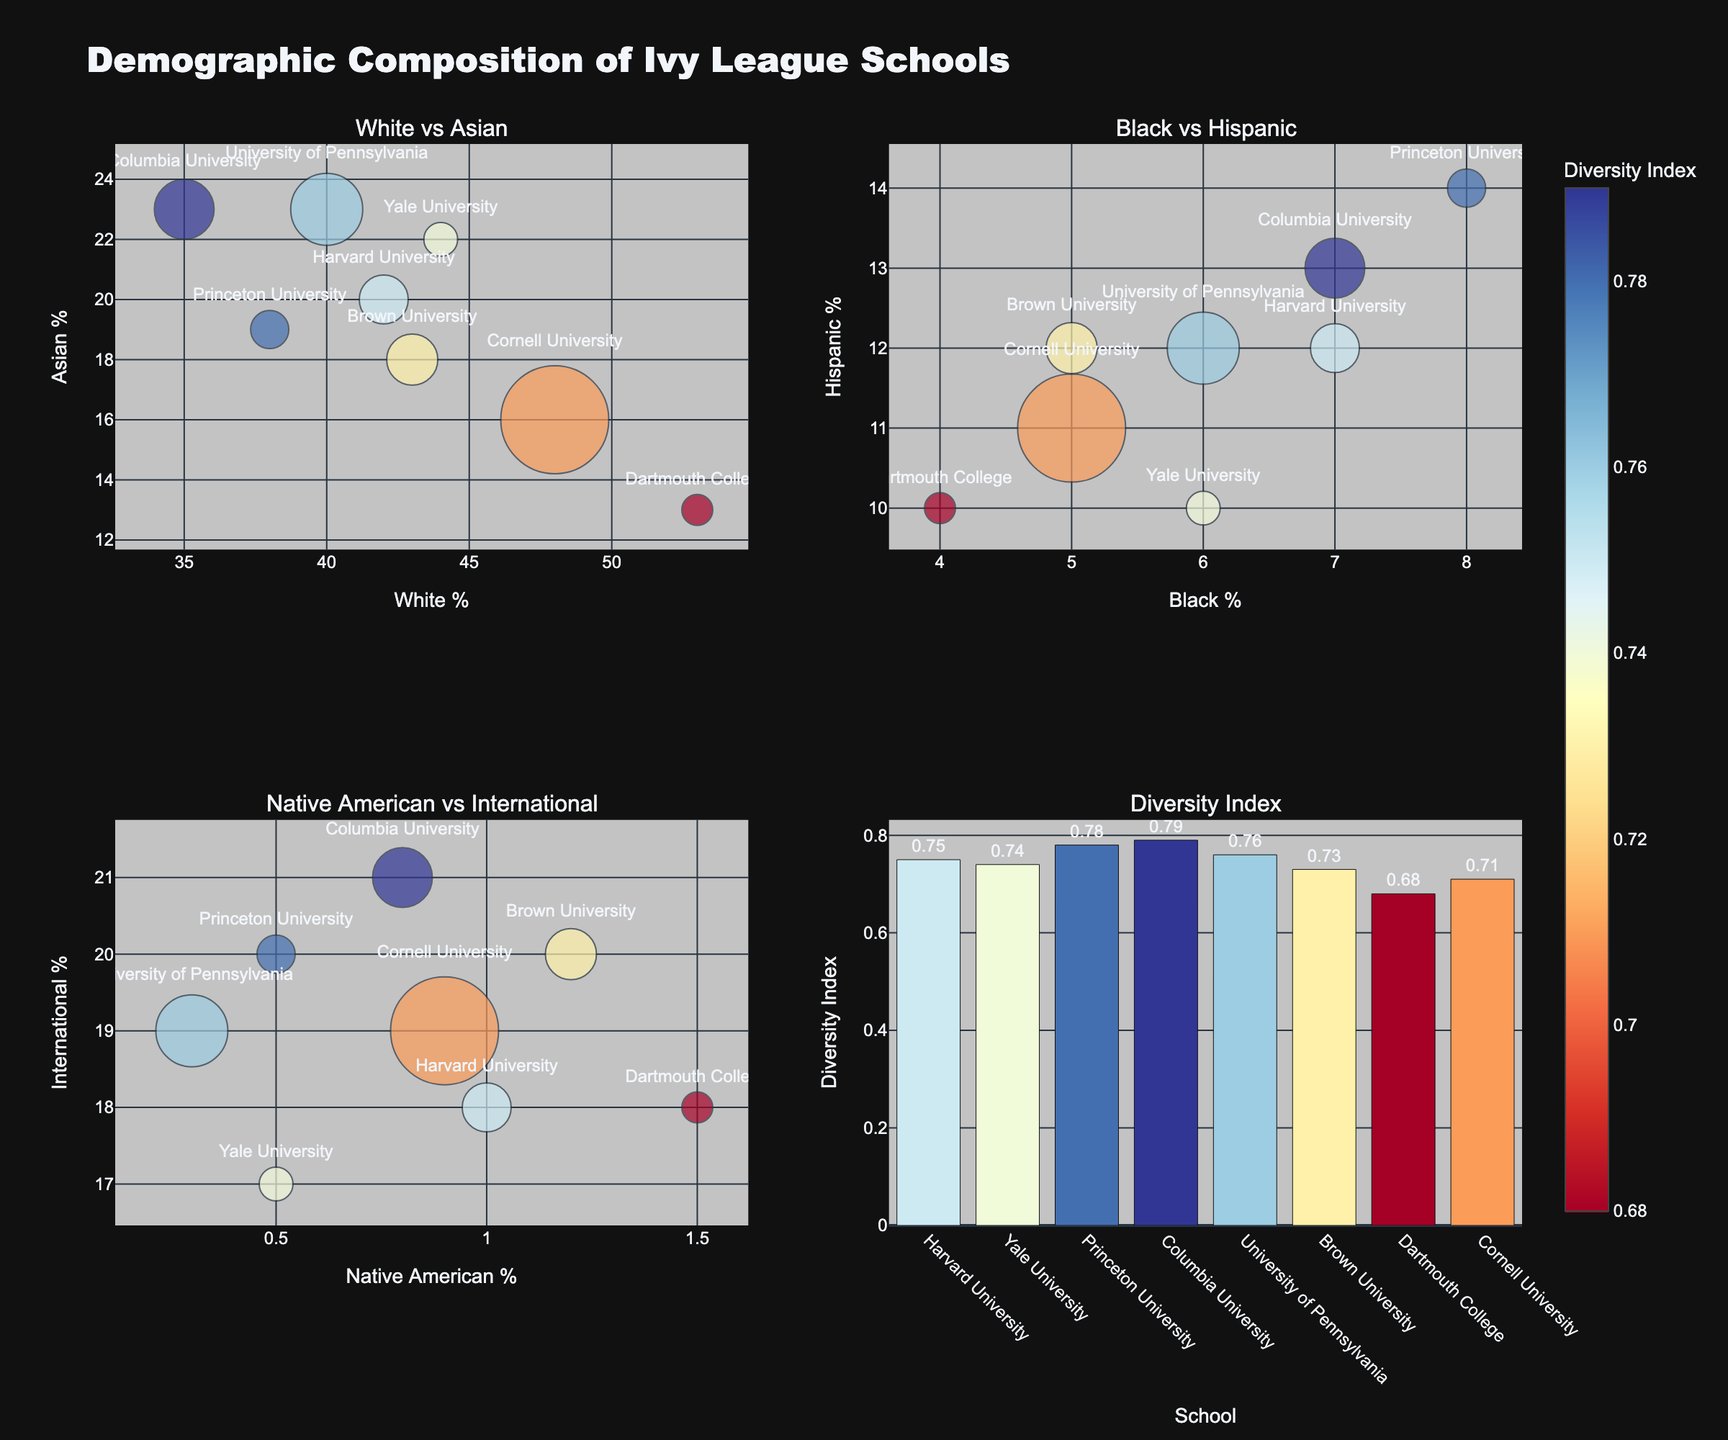What's the title of the figure? The title is prominently displayed at the top center of the figure.
Answer: Demographic Composition of Ivy League Schools What is the diversity index of Columbia University? Look at the bar chart in the bottom right-bottom subplot. Find the bar labeled "Columbia University" and check the value of the diversity index.
Answer: 0.79 Which university has the highest percentage of Asian students? Refer to the "White vs Asian" bubble chart at the top-left subplot. Look for the bubble with the highest y-axis value (Asian %) and check the corresponding university label.
Answer: Columbia University How does Dartmouth College compare to other schools in terms of White and Black student percentages? Refer to both the "White vs Asian" (top-left) and "Black vs Hispanic" (top-right) bubble charts. Notice that Dartmouth has the highest White % and one of the lowest Black %. This means Dartmouth has the highest percentage of White students and relatively low percentage of Black students compared to other schools.
Answer: Highest White %, Low Black % Rank the schools by their undergrad enrollment from largest to smallest. Refer to the size of the bubbles in any of the bubble charts. Larger bubbles indicate larger enrollments. Order the schools by bubble size: Cornell, University of Pennsylvania, Columbia, Brown, Harvard, Princeton, Yale, Dartmouth.
Answer: Cornell, University of Pennsylvania, Columbia, Brown, Harvard, Princeton, Yale, Dartmouth Which two schools have the closest percentages of Hispanic students? Refer to the "Black vs Hispanic" bubble chart (top-right subplot). Compare the y-axis (Hispanic %) values to find the closest two.
Answer: Yale University and Dartmouth College What are the axes titles for the "Native American vs International" subplot? For the "Native American vs International" subplot located at the bottom-left, the x-axis title is "Native American %" and the y-axis title is "International %".
Answer: Native American % (x-Axis), International % (y-Axis) Which school has the highest diversity index and what value is it? Refer to the bar chart in the bottom-right subplot. The highest bar represents the school with the highest diversity index. Check the label and the corresponding value for this bar.
Answer: Columbia University, 0.79 